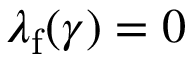Convert formula to latex. <formula><loc_0><loc_0><loc_500><loc_500>\lambda _ { f } ( \gamma ) = 0</formula> 